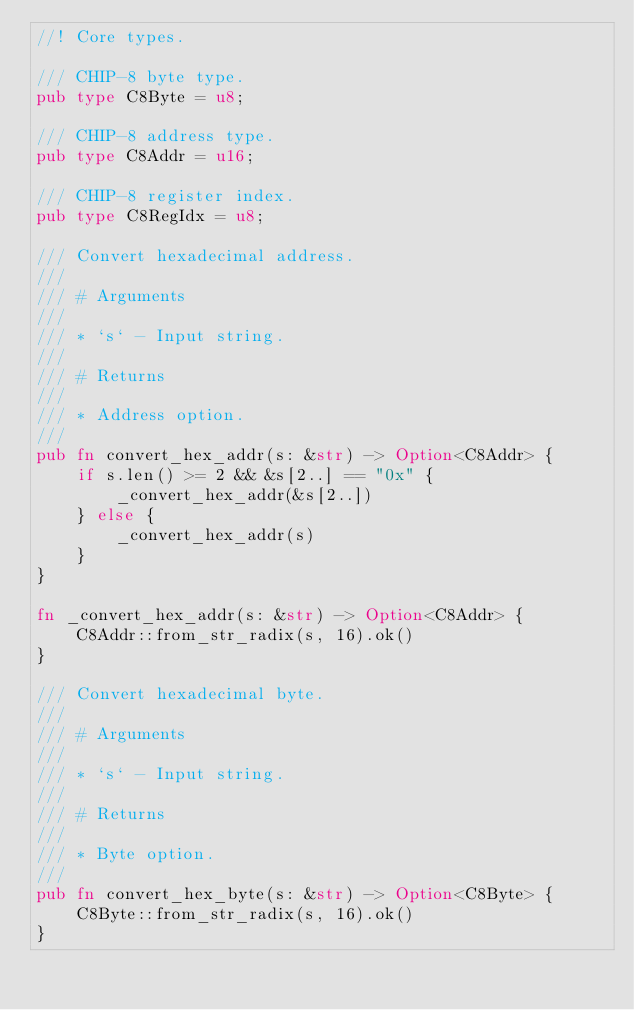<code> <loc_0><loc_0><loc_500><loc_500><_Rust_>//! Core types.

/// CHIP-8 byte type.
pub type C8Byte = u8;

/// CHIP-8 address type.
pub type C8Addr = u16;

/// CHIP-8 register index.
pub type C8RegIdx = u8;

/// Convert hexadecimal address.
///
/// # Arguments
///
/// * `s` - Input string.
///
/// # Returns
///
/// * Address option.
///
pub fn convert_hex_addr(s: &str) -> Option<C8Addr> {
    if s.len() >= 2 && &s[2..] == "0x" {
        _convert_hex_addr(&s[2..])
    } else {
        _convert_hex_addr(s)
    }
}

fn _convert_hex_addr(s: &str) -> Option<C8Addr> {
    C8Addr::from_str_radix(s, 16).ok()
}

/// Convert hexadecimal byte.
///
/// # Arguments
///
/// * `s` - Input string.
///
/// # Returns
///
/// * Byte option.
///
pub fn convert_hex_byte(s: &str) -> Option<C8Byte> {
    C8Byte::from_str_radix(s, 16).ok()
}
</code> 